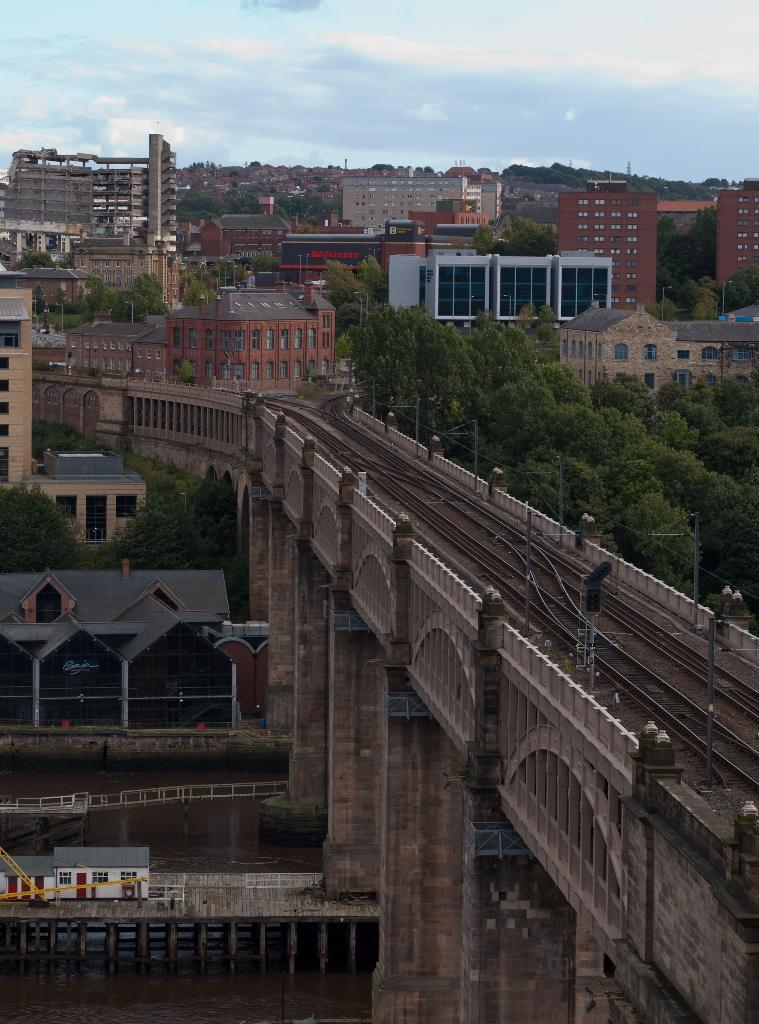What type of structure is present in the image? There is a railway bridge in the image. What other objects can be seen in the image? There are trees and buildings visible in the image. What is visible in the background of the image? The sky is visible in the background of the image. What can be observed in the sky? There are clouds in the sky. What type of wrench is being used to repair the ship in the image? There is no ship or wrench present in the image; it features a railway bridge, trees, buildings, and a sky with clouds. 